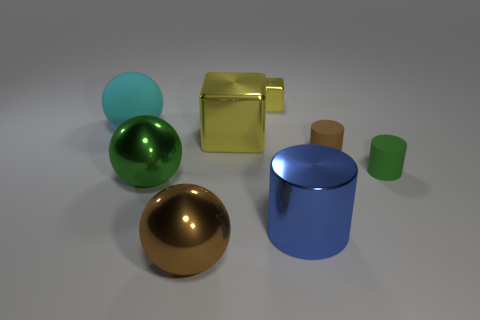Add 2 big cylinders. How many objects exist? 10 Subtract all small matte cylinders. How many cylinders are left? 1 Subtract 1 cylinders. How many cylinders are left? 2 Subtract all cylinders. How many objects are left? 5 Subtract all small yellow blocks. Subtract all small cylinders. How many objects are left? 5 Add 7 yellow things. How many yellow things are left? 9 Add 4 purple spheres. How many purple spheres exist? 4 Subtract 0 blue spheres. How many objects are left? 8 Subtract all green balls. Subtract all blue blocks. How many balls are left? 2 